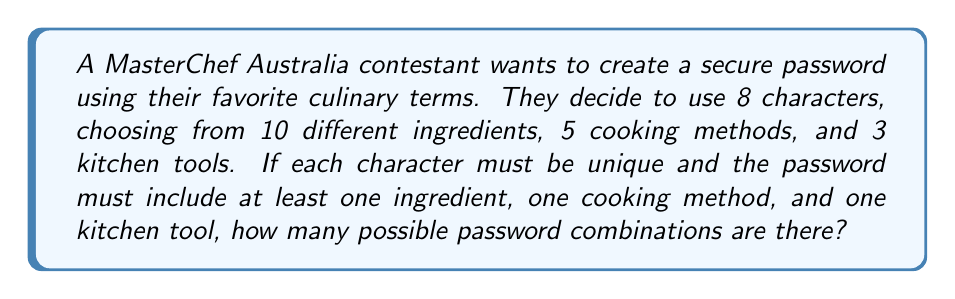Provide a solution to this math problem. Let's approach this step-by-step:

1) First, we need to calculate the total number of characters available:
   $10 + 5 + 3 = 18$ characters in total

2) We need to use the permutation formula, as order matters in a password and each character can only be used once.

3) The formula for permutations is:
   $P(n,r) = \frac{n!}{(n-r)!}$
   Where $n$ is the total number of items to choose from, and $r$ is the number of items being chosen.

4) In this case, $n = 18$ and $r = 8$

5) Plugging these into our formula:
   $P(18,8) = \frac{18!}{(18-8)!} = \frac{18!}{10!}$

6) However, this calculates all possible combinations, including those that don't meet our criteria of having at least one ingredient, one cooking method, and one kitchen tool.

7) To ensure we meet these criteria, we can use the principle of inclusion-exclusion:

   Total = All combinations - (Combinations without ingredients + Combinations without cooking methods + Combinations without kitchen tools - Combinations without ingredients and cooking methods - Combinations without ingredients and kitchen tools - Combinations without cooking methods and kitchen tools + Combinations without any of the three)

8) Let's calculate each of these:
   - All combinations: $\frac{18!}{10!}$
   - Without ingredients: $\frac{8!}{0!}$
   - Without cooking methods: $\frac{13!}{5!}$
   - Without kitchen tools: $\frac{15!}{7!}$
   - Without ingredients and cooking methods: $\frac{3!}{0!}$
   - Without ingredients and kitchen tools: $\frac{5!}{0!}$
   - Without cooking methods and kitchen tools: $\frac{10!}{2!}$
   - Without any of the three: $0!$

9) Putting it all together:

   $$\frac{18!}{10!} - (\frac{8!}{0!} + \frac{13!}{5!} + \frac{15!}{7!} - \frac{3!}{0!} - \frac{5!}{0!} - \frac{10!}{2!} + 0!)$$

10) Calculating this gives us the final answer.
Answer: 1,679,616,000 